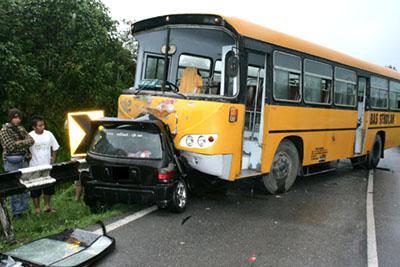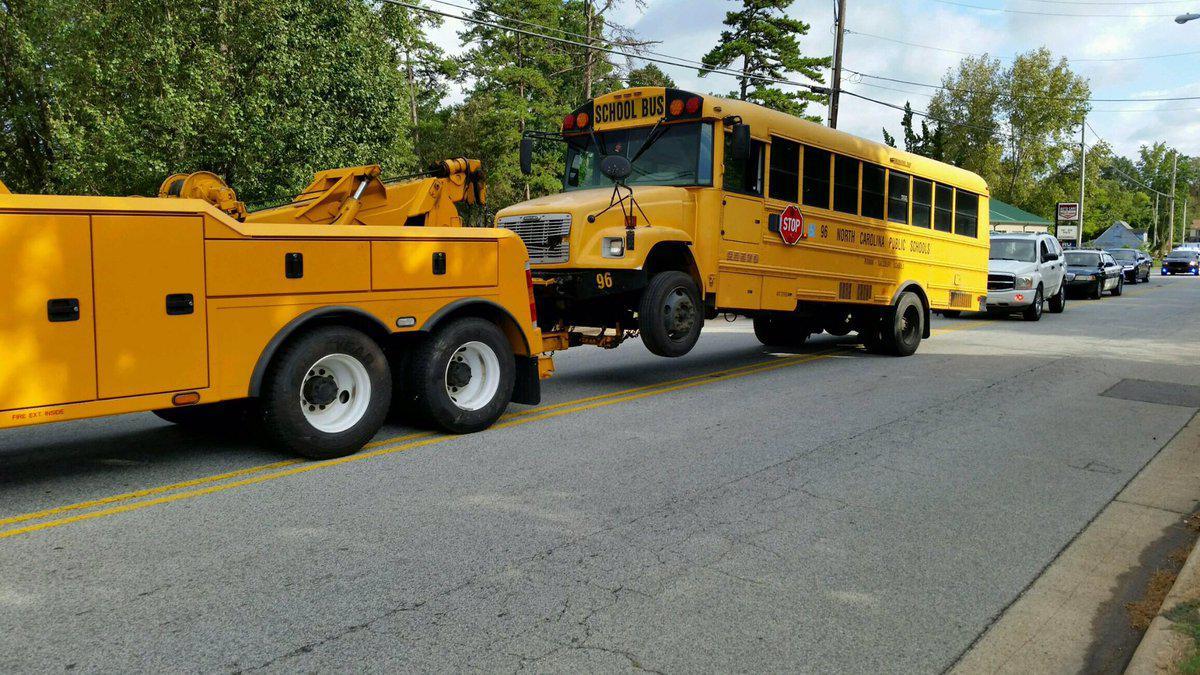The first image is the image on the left, the second image is the image on the right. Considering the images on both sides, is "People are standing outside near a bus in the image on the left." valid? Answer yes or no. Yes. 